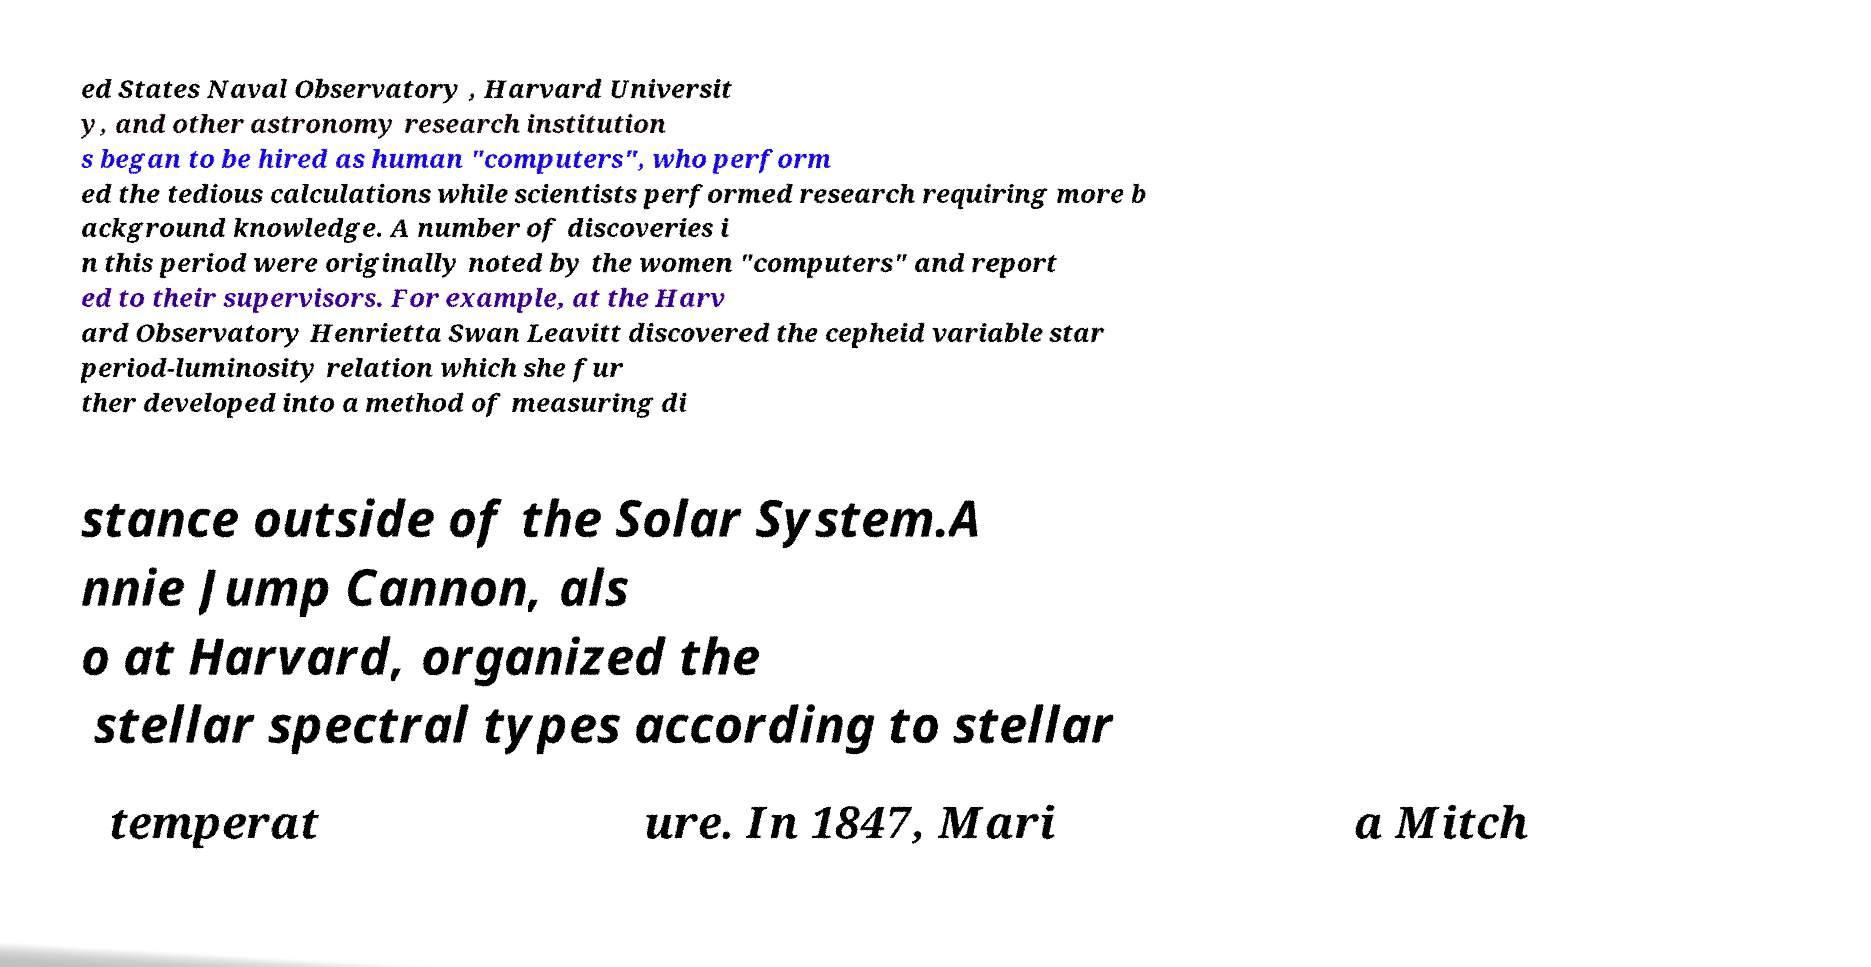I need the written content from this picture converted into text. Can you do that? ed States Naval Observatory , Harvard Universit y, and other astronomy research institution s began to be hired as human "computers", who perform ed the tedious calculations while scientists performed research requiring more b ackground knowledge. A number of discoveries i n this period were originally noted by the women "computers" and report ed to their supervisors. For example, at the Harv ard Observatory Henrietta Swan Leavitt discovered the cepheid variable star period-luminosity relation which she fur ther developed into a method of measuring di stance outside of the Solar System.A nnie Jump Cannon, als o at Harvard, organized the stellar spectral types according to stellar temperat ure. In 1847, Mari a Mitch 